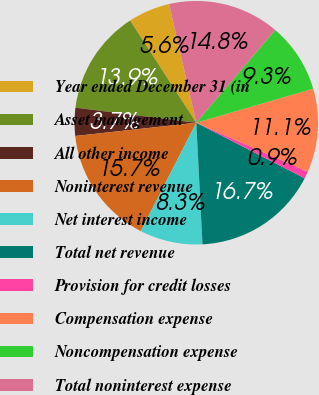Convert chart to OTSL. <chart><loc_0><loc_0><loc_500><loc_500><pie_chart><fcel>Year ended December 31 (in<fcel>Asset management<fcel>All other income<fcel>Noninterest revenue<fcel>Net interest income<fcel>Total net revenue<fcel>Provision for credit losses<fcel>Compensation expense<fcel>Noncompensation expense<fcel>Total noninterest expense<nl><fcel>5.56%<fcel>13.88%<fcel>3.71%<fcel>15.73%<fcel>8.34%<fcel>16.66%<fcel>0.94%<fcel>11.11%<fcel>9.26%<fcel>14.81%<nl></chart> 